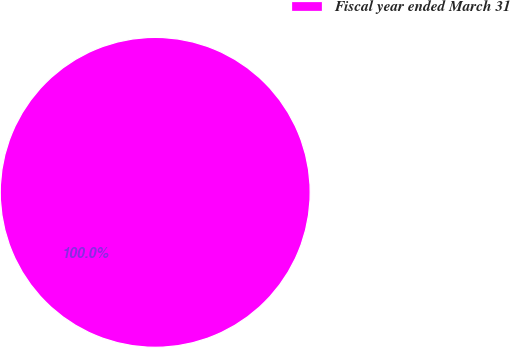<chart> <loc_0><loc_0><loc_500><loc_500><pie_chart><fcel>Fiscal year ended March 31<nl><fcel>100.0%<nl></chart> 